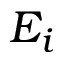<formula> <loc_0><loc_0><loc_500><loc_500>E _ { i }</formula> 